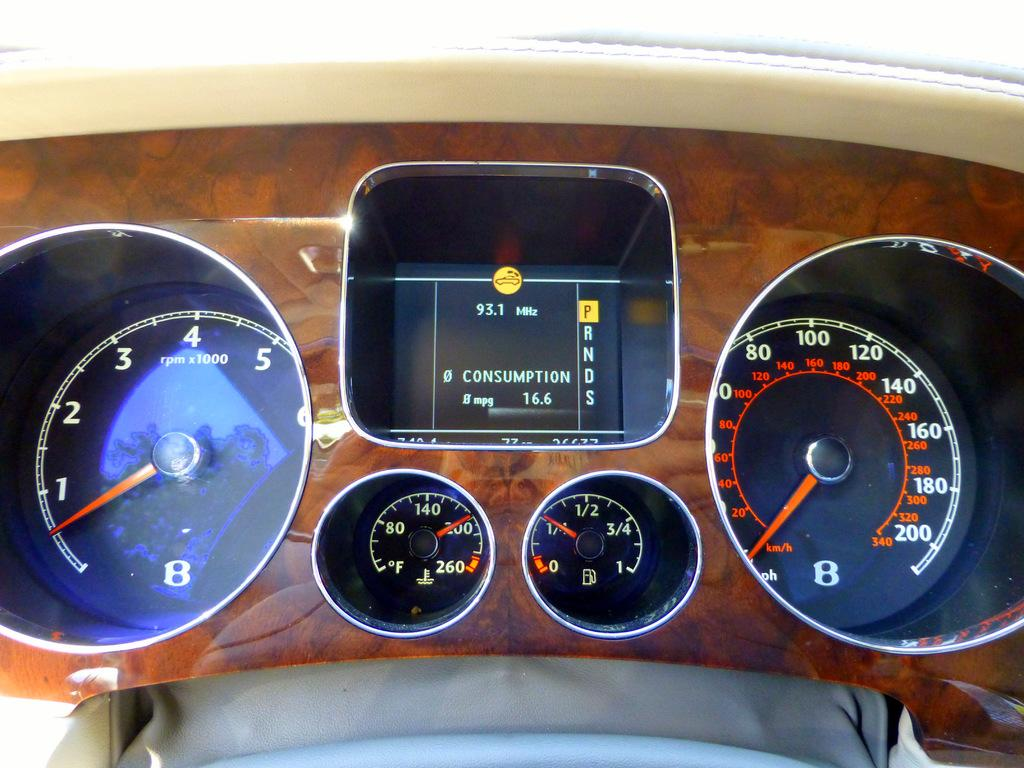What type of device is visible in the image? There is a speedometer in the image. Are there any other similar devices in the image? Yes, there are other meters in the image. What is the color of the background in the image? The background of the image has a brown color. Is there a volcano erupting in the background of the image? No, there is no volcano or any indication of an eruption in the image. 